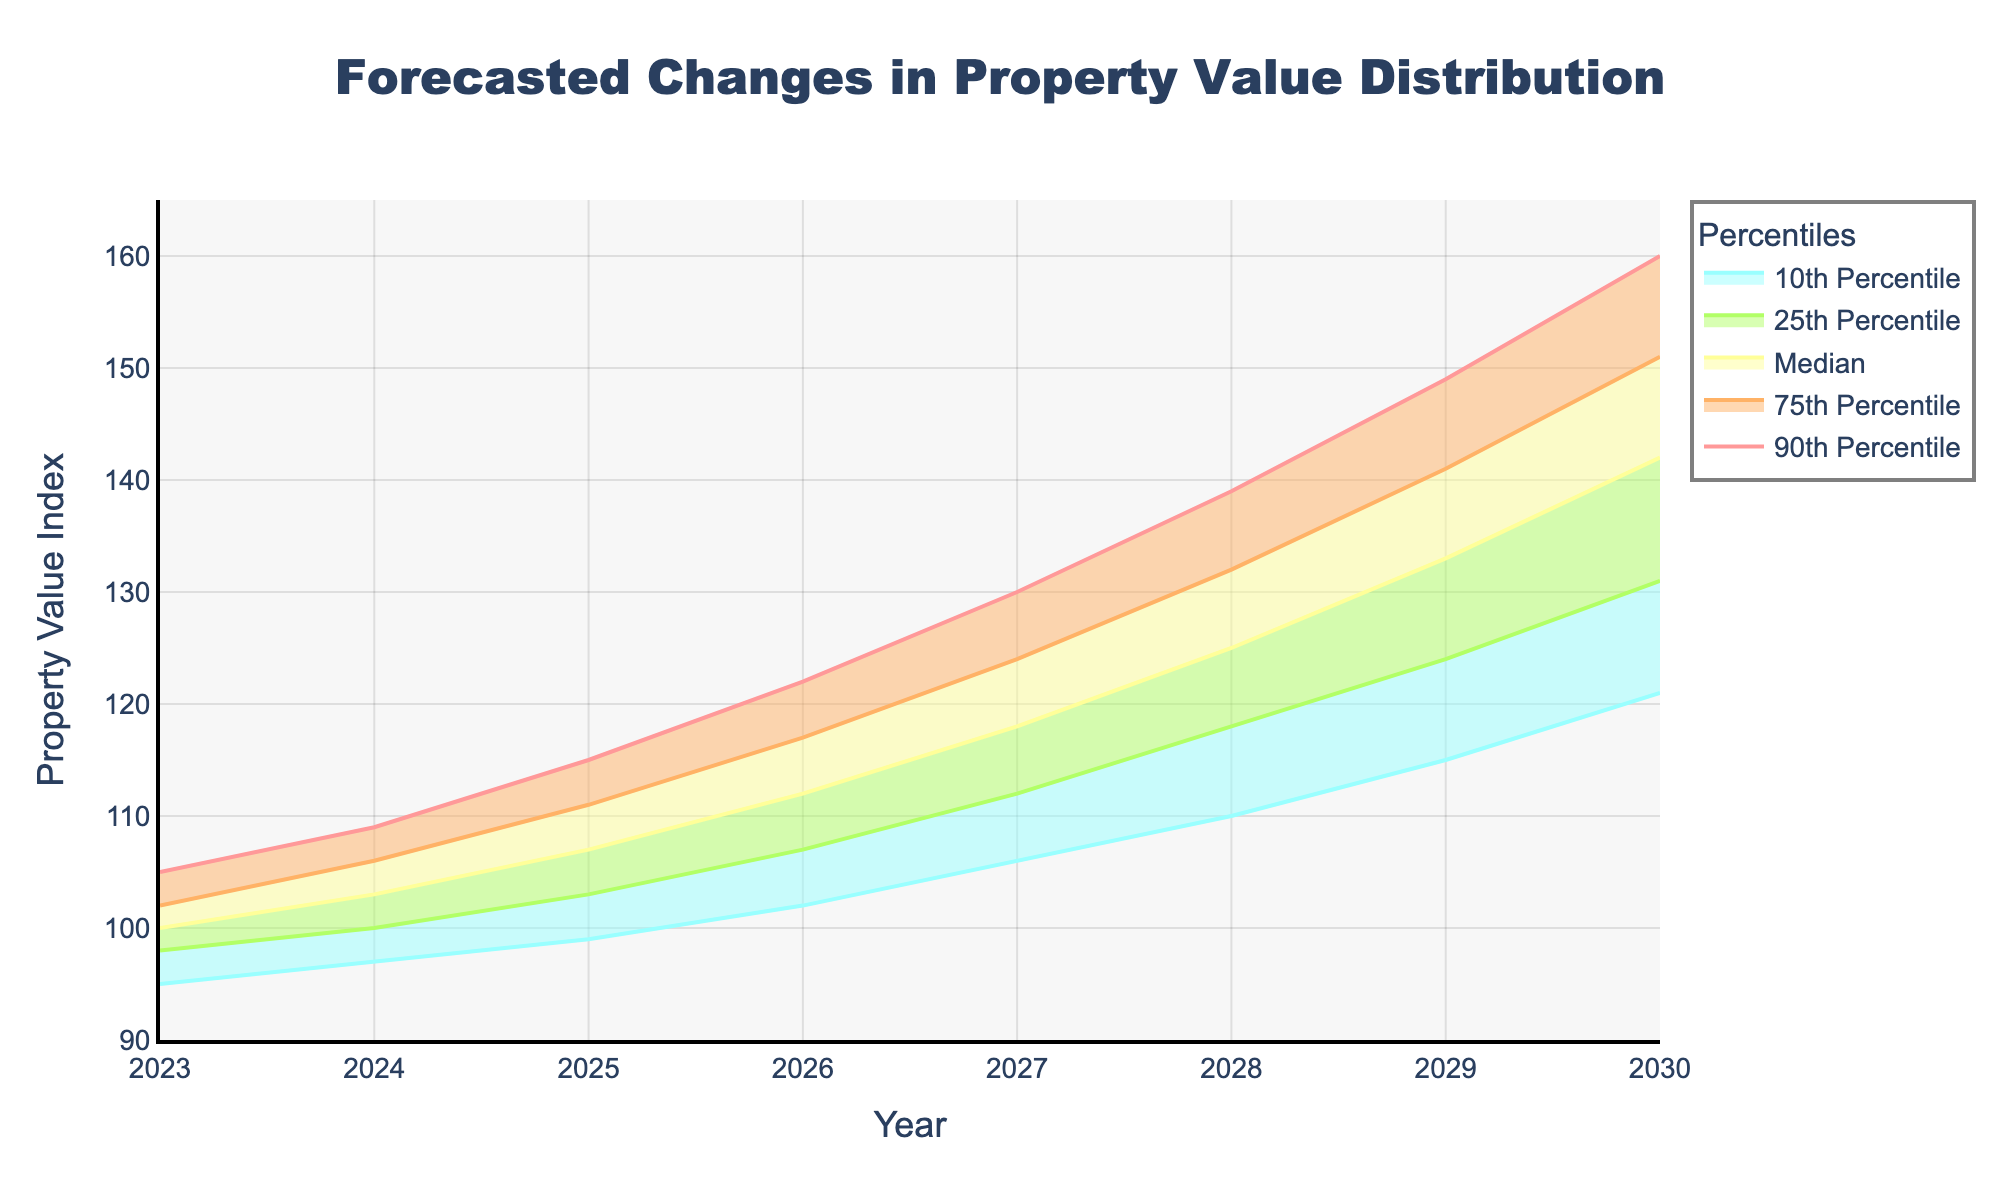What's the title of the chart? The title of the chart is located at the top of the figure and usually describes the main topic the chart covers. In this chart, the title is prominently displayed.
Answer: Forecasted Changes in Property Value Distribution Which year has the highest median property value? By examining the "Median" line in the chart, which is often the central or middle line, we see that the highest point of this line occurs in 2030.
Answer: 2030 What's the average of the median property values from 2023 to 2025? To find the average, add the median values for 2023, 2024, and 2025 (100, 103, 107) and then divide by the number of years (3). \( \frac{100 + 103 + 107}{3} = 103.33 \)
Answer: 103.33 How much does the 10th percentile increase from 2023 to 2029? Subtract the 10th percentile value in 2023 from the 10th percentile value in 2029. \( 115 - 95 = 20 \)
Answer: 20 Is the property value distribution getting more spread out or more narrow over the years? By comparing the range (difference between 10th and 90th percentile) over the years, we see the range increases from 10 (105-95) in 2023 to 34 (149-115) in 2029, indicating a more spread-out distribution.
Answer: More spread out Which percentile shows the largest increase from 2023 to 2028? By checking the increases for each percentile individually, we see the 75th percentile increases by 30 units (132-102), which is larger than the increases for the other percentiles.
Answer: 75th Percentile What is the trend in the 25th percentile from 2024 to 2027? Observing the 25th percentile line on the chart between these years, we see that it consistently rises from 100 to 112.
Answer: Increasing In 2025, which is greater, the median property value or the 10th percentile value in 2026? Compare the median value of 107 in 2025 with the 10th percentile value of 102 in 2026. Since 107 is greater than 102, the median value in 2025 is greater.
Answer: Median property value What can you infer about property values if they follow the trend shown for the next decade? If the current trends of increased percentiles and wider spread continue, property values will continue to rise, and the difference between low and high values will widen.
Answer: Increasing and more spread out 